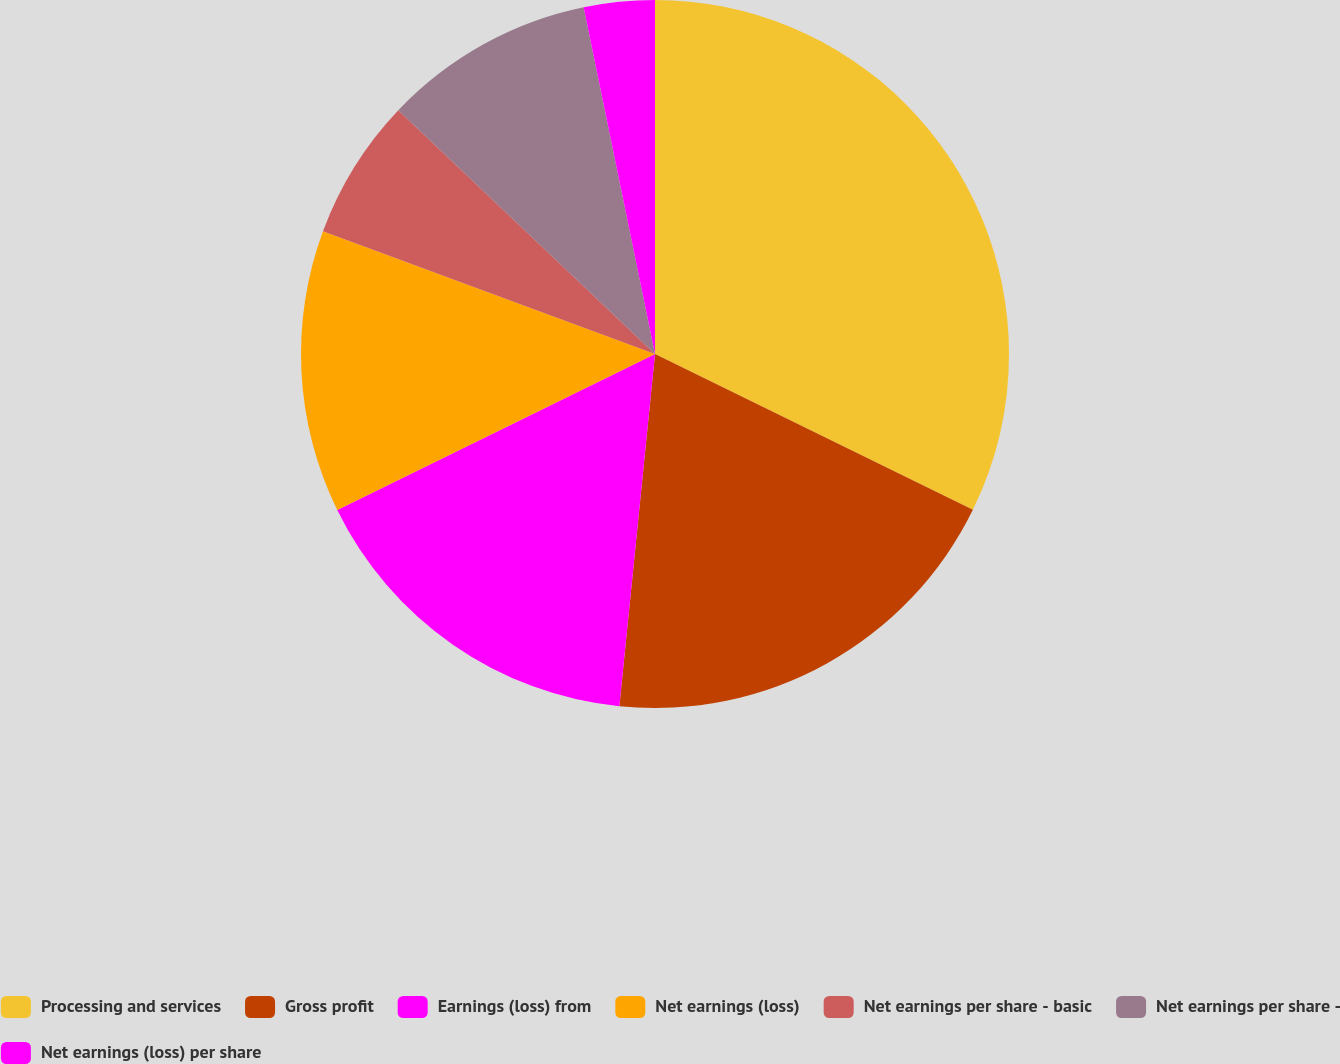<chart> <loc_0><loc_0><loc_500><loc_500><pie_chart><fcel>Processing and services<fcel>Gross profit<fcel>Earnings (loss) from<fcel>Net earnings (loss)<fcel>Net earnings per share - basic<fcel>Net earnings per share -<fcel>Net earnings (loss) per share<nl><fcel>32.25%<fcel>19.35%<fcel>16.13%<fcel>12.9%<fcel>6.45%<fcel>9.68%<fcel>3.23%<nl></chart> 